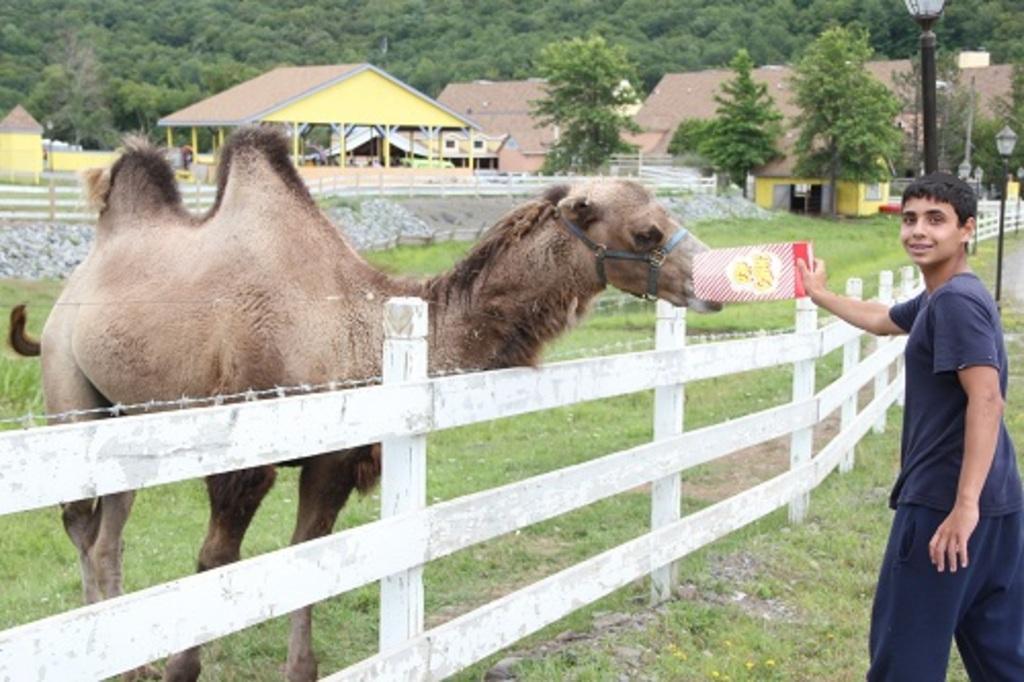In one or two sentences, can you explain what this image depicts? In the front of the image there is a railing, grass, animal and a person. Person is holding an object. In the background of the image there are houses, open-shed, trees, light poles, board, rocks, railing and objects. 